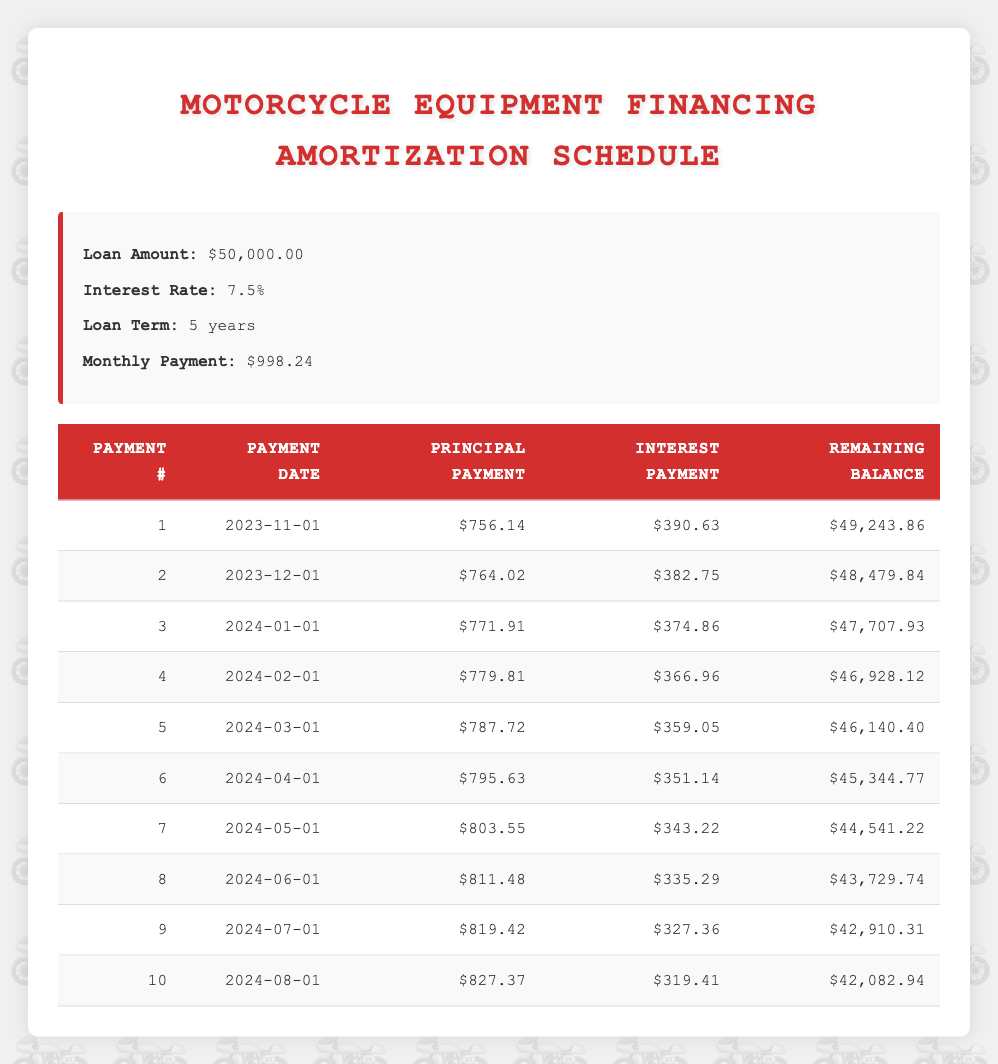What is the principal payment in the first month? The first month's principal payment is listed directly in the table under the "Principal Payment" column for payment number one, which shows a value of 756.14.
Answer: 756.14 What is the total interest paid in the first three months? To find the total interest paid in the first three months, we add the interest payments for those months: 390.63 (month 1) + 382.75 (month 2) + 374.86 (month 3) = 1148.24.
Answer: 1148.24 Is the interest payment in the second month less than the interest payment in the fourth month? In the second month, the interest payment is 382.75, and in the fourth month, it is 366.96. Since 382.75 is greater than 366.96, the statement is false.
Answer: No What is the remaining balance after the 10th payment? The remaining balance after the 10th payment is specifically provided in the table under the "Remaining Balance" column for payment number 10, which shows a value of 42,082.94.
Answer: 42,082.94 How much total principal is paid by the end of the sixth month? To calculate the total principal paid by the sixth month, we sum the principal payments from the first to the sixth month: 756.14 + 764.02 + 771.91 + 779.81 + 787.72 + 795.63 = 4,061.23.
Answer: 4,061.23 What is the difference between the interest payments of the first and the last month listed? The interest payment in the first month is 390.63, while the last month shown (tenth month) is 319.41. The difference is calculated as 390.63 - 319.41 = 71.22.
Answer: 71.22 Is the total monthly payment more than the monthly payment in the fifth month? The total monthly payment is 998.24, and the monthly payment in the fifth month is also 998.24. Since they are equal, the statement is false.
Answer: No What is the average principal payment over the first 10 months? To find the average principal payment, first sum the principal payments for the first 10 months: 756.14 + 764.02 + 771.91 + 779.81 + 787.72 + 795.63 + 803.55 + 811.48 + 819.42 + 827.37 = 7,335.03. Then, divide by 10 (the number of months): 7,335.03 / 10 = 733.503.
Answer: 733.503 Which payment number has the highest principal payment, and what is its value? The table shows that the highest principal payment occurs in the tenth month (payment number 10) with a value of 827.37.
Answer: 10, 827.37 